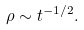<formula> <loc_0><loc_0><loc_500><loc_500>\rho \sim t ^ { - 1 / 2 } .</formula> 